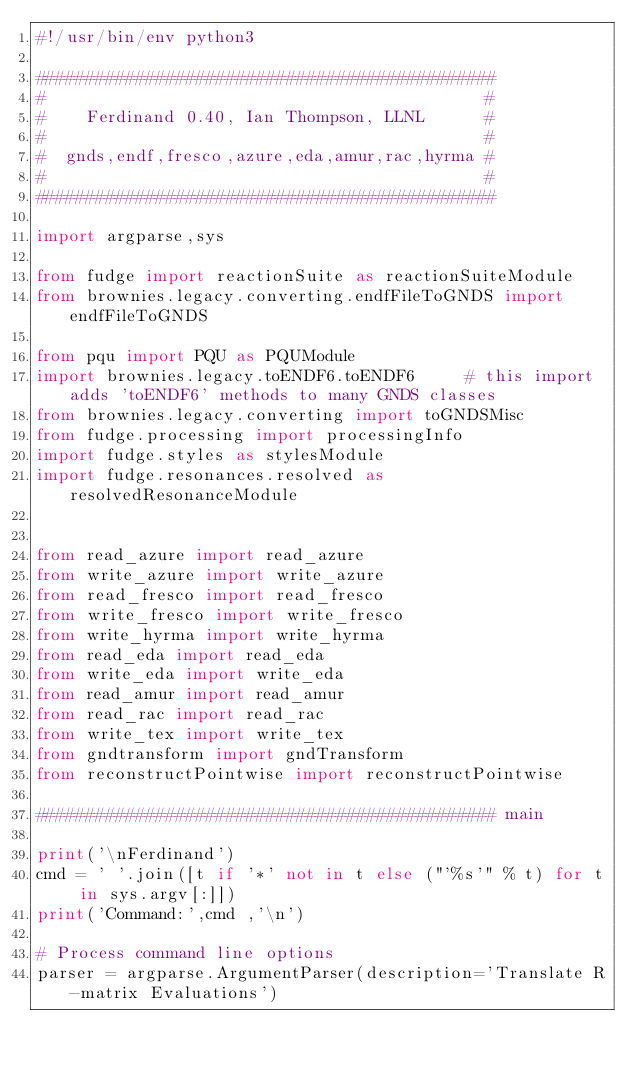Convert code to text. <code><loc_0><loc_0><loc_500><loc_500><_Python_>#!/usr/bin/env python3

##############################################
#                                            #
#    Ferdinand 0.40, Ian Thompson, LLNL      #
#                                            #
#  gnds,endf,fresco,azure,eda,amur,rac,hyrma #
#                                            #
##############################################

import argparse,sys

from fudge import reactionSuite as reactionSuiteModule
from brownies.legacy.converting.endfFileToGNDS import endfFileToGNDS

from pqu import PQU as PQUModule
import brownies.legacy.toENDF6.toENDF6     # this import adds 'toENDF6' methods to many GNDS classes
from brownies.legacy.converting import toGNDSMisc
from fudge.processing import processingInfo
import fudge.styles as stylesModule
import fudge.resonances.resolved as resolvedResonanceModule


from read_azure import read_azure
from write_azure import write_azure
from read_fresco import read_fresco
from write_fresco import write_fresco
from write_hyrma import write_hyrma
from read_eda import read_eda
from write_eda import write_eda
from read_amur import read_amur
from read_rac import read_rac
from write_tex import write_tex
from gndtransform import gndTransform
from reconstructPointwise import reconstructPointwise

############################################## main

print('\nFerdinand')
cmd = ' '.join([t if '*' not in t else ("'%s'" % t) for t in sys.argv[:]])
print('Command:',cmd ,'\n')

# Process command line options
parser = argparse.ArgumentParser(description='Translate R-matrix Evaluations')</code> 